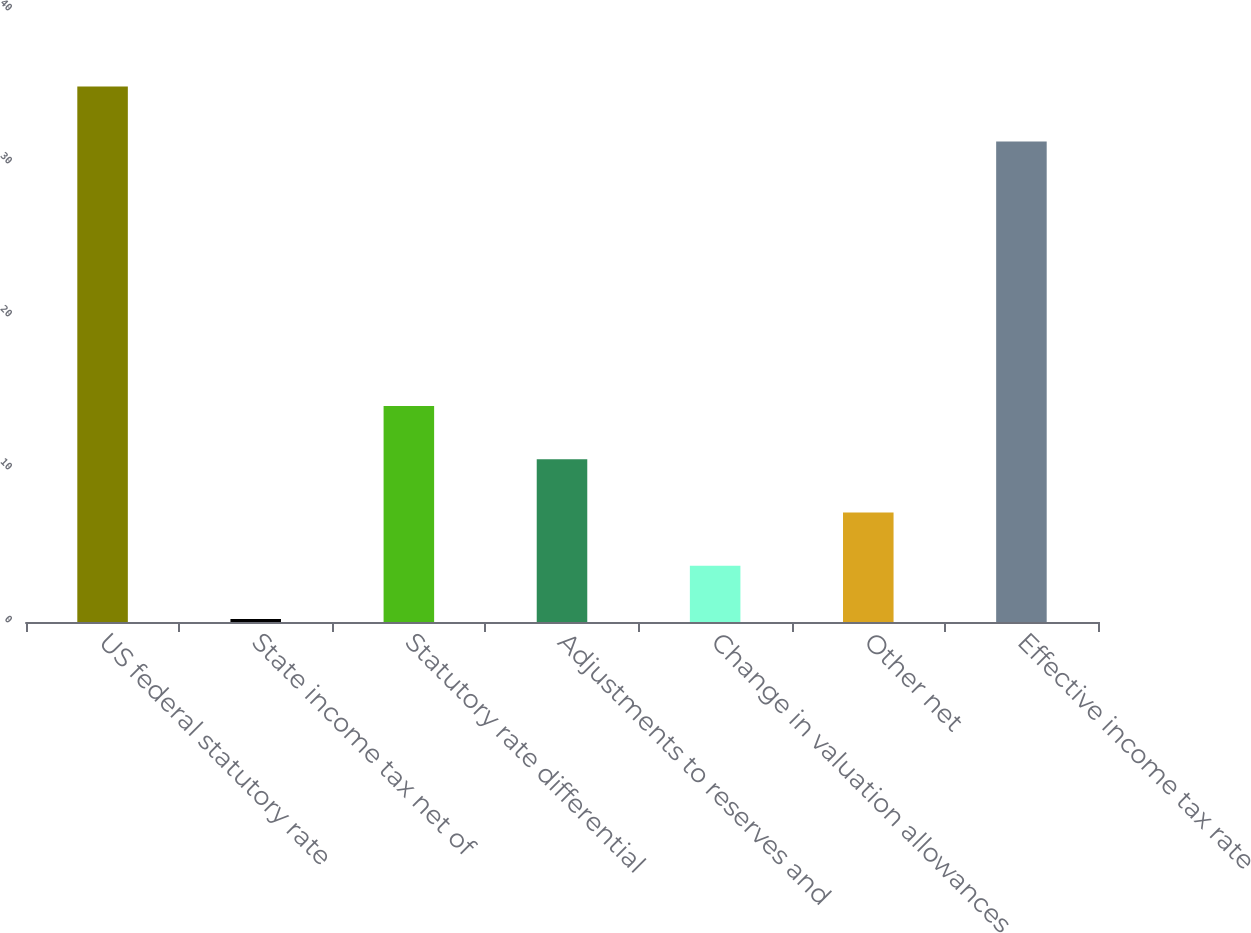<chart> <loc_0><loc_0><loc_500><loc_500><bar_chart><fcel>US federal statutory rate<fcel>State income tax net of<fcel>Statutory rate differential<fcel>Adjustments to reserves and<fcel>Change in valuation allowances<fcel>Other net<fcel>Effective income tax rate<nl><fcel>35<fcel>0.2<fcel>14.12<fcel>10.64<fcel>3.68<fcel>7.16<fcel>31.4<nl></chart> 